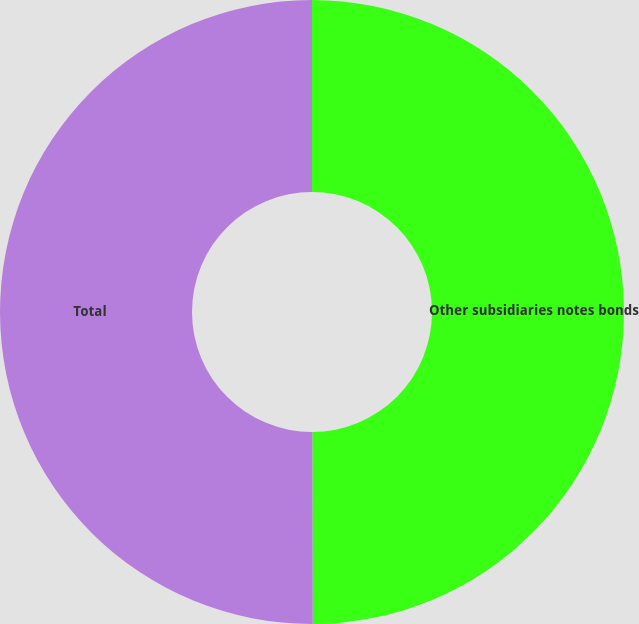<chart> <loc_0><loc_0><loc_500><loc_500><pie_chart><fcel>Other subsidiaries notes bonds<fcel>Total<nl><fcel>49.96%<fcel>50.04%<nl></chart> 